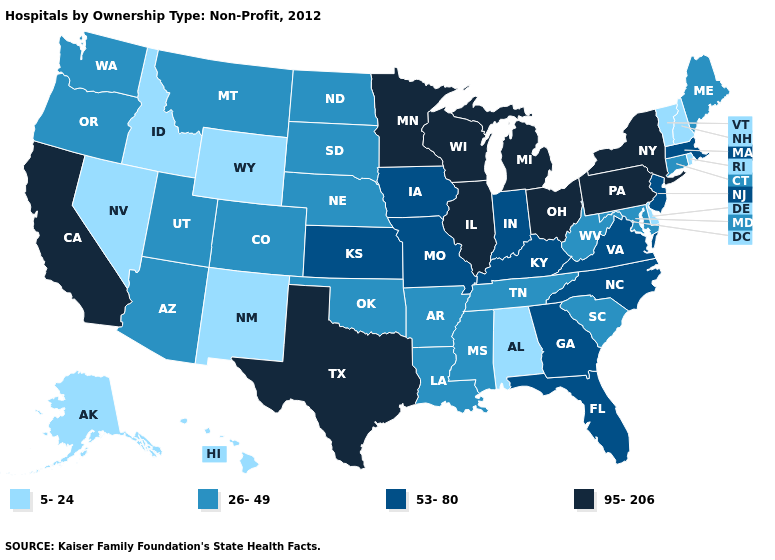What is the value of Louisiana?
Be succinct. 26-49. Name the states that have a value in the range 53-80?
Keep it brief. Florida, Georgia, Indiana, Iowa, Kansas, Kentucky, Massachusetts, Missouri, New Jersey, North Carolina, Virginia. Name the states that have a value in the range 5-24?
Be succinct. Alabama, Alaska, Delaware, Hawaii, Idaho, Nevada, New Hampshire, New Mexico, Rhode Island, Vermont, Wyoming. What is the lowest value in the MidWest?
Keep it brief. 26-49. Is the legend a continuous bar?
Concise answer only. No. How many symbols are there in the legend?
Give a very brief answer. 4. Does the map have missing data?
Answer briefly. No. Does Alabama have a lower value than Hawaii?
Give a very brief answer. No. Which states have the highest value in the USA?
Give a very brief answer. California, Illinois, Michigan, Minnesota, New York, Ohio, Pennsylvania, Texas, Wisconsin. Name the states that have a value in the range 53-80?
Write a very short answer. Florida, Georgia, Indiana, Iowa, Kansas, Kentucky, Massachusetts, Missouri, New Jersey, North Carolina, Virginia. Does California have the highest value in the West?
Be succinct. Yes. What is the value of Louisiana?
Write a very short answer. 26-49. Among the states that border Pennsylvania , does Ohio have the highest value?
Give a very brief answer. Yes. Among the states that border New York , which have the highest value?
Give a very brief answer. Pennsylvania. What is the lowest value in states that border Texas?
Answer briefly. 5-24. 